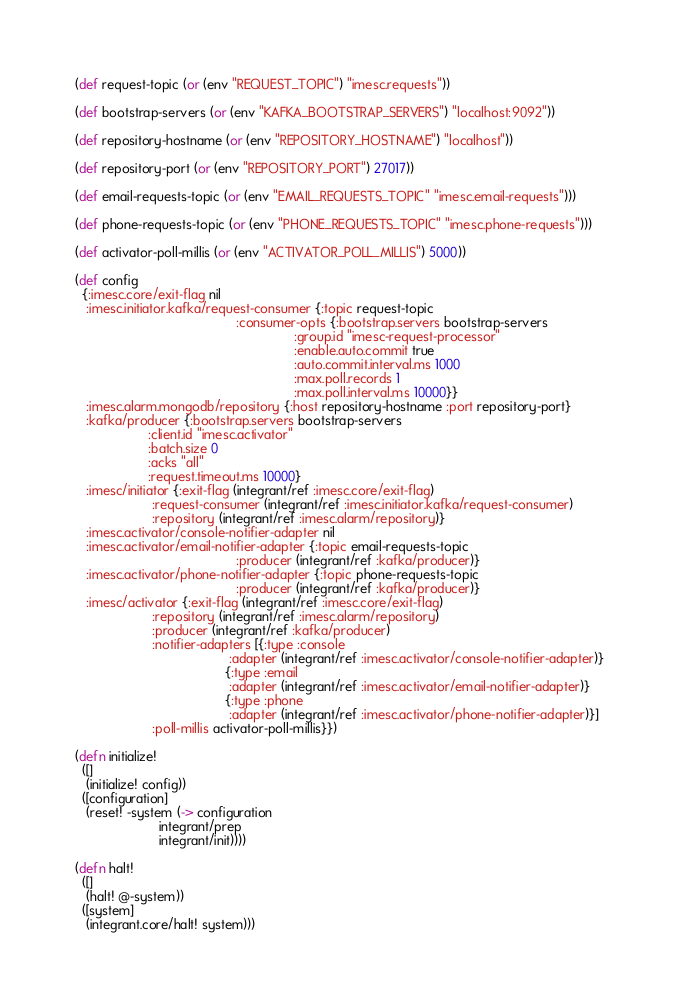<code> <loc_0><loc_0><loc_500><loc_500><_Clojure_>
(def request-topic (or (env "REQUEST_TOPIC") "imesc.requests"))

(def bootstrap-servers (or (env "KAFKA_BOOTSTRAP_SERVERS") "localhost:9092"))

(def repository-hostname (or (env "REPOSITORY_HOSTNAME") "localhost"))

(def repository-port (or (env "REPOSITORY_PORT") 27017))

(def email-requests-topic (or (env "EMAIL_REQUESTS_TOPIC" "imesc.email-requests")))

(def phone-requests-topic (or (env "PHONE_REQUESTS_TOPIC" "imesc.phone-requests")))

(def activator-poll-millis (or (env "ACTIVATOR_POLL_MILLIS") 5000))

(def config
  {:imesc.core/exit-flag nil
   :imesc.initiator.kafka/request-consumer {:topic request-topic
                                            :consumer-opts {:bootstrap.servers bootstrap-servers
                                                            :group.id "imesc-request-processor"
                                                            :enable.auto.commit true
                                                            :auto.commit.interval.ms 1000
                                                            :max.poll.records 1
                                                            :max.poll.interval.ms 10000}}
   :imesc.alarm.mongodb/repository {:host repository-hostname :port repository-port}
   :kafka/producer {:bootstrap.servers bootstrap-servers
                    :client.id "imesc.activator"
                    :batch.size 0
                    :acks "all"
                    :request.timeout.ms 10000}
   :imesc/initiator {:exit-flag (integrant/ref :imesc.core/exit-flag)
                     :request-consumer (integrant/ref :imesc.initiator.kafka/request-consumer)
                     :repository (integrant/ref :imesc.alarm/repository)}
   :imesc.activator/console-notifier-adapter nil
   :imesc.activator/email-notifier-adapter {:topic email-requests-topic
                                            :producer (integrant/ref :kafka/producer)}
   :imesc.activator/phone-notifier-adapter {:topic phone-requests-topic
                                            :producer (integrant/ref :kafka/producer)}
   :imesc/activator {:exit-flag (integrant/ref :imesc.core/exit-flag)
                     :repository (integrant/ref :imesc.alarm/repository)
                     :producer (integrant/ref :kafka/producer)
                     :notifier-adapters [{:type :console
                                          :adapter (integrant/ref :imesc.activator/console-notifier-adapter)}
                                         {:type :email
                                          :adapter (integrant/ref :imesc.activator/email-notifier-adapter)}
                                         {:type :phone
                                          :adapter (integrant/ref :imesc.activator/phone-notifier-adapter)}]
                     :poll-millis activator-poll-millis}})

(defn initialize!
  ([]
   (initialize! config))
  ([configuration]
   (reset! -system (-> configuration
                       integrant/prep
                       integrant/init))))

(defn halt!
  ([]
   (halt! @-system))
  ([system]
   (integrant.core/halt! system)))


</code> 